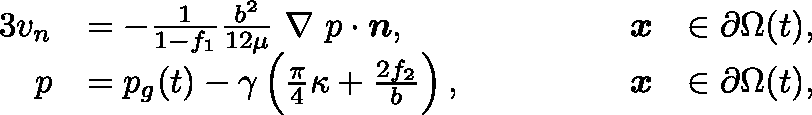<formula> <loc_0><loc_0><loc_500><loc_500>\begin{array} { r l r l } { { 3 } v _ { n } } & { = - \frac { 1 } { 1 - f _ { 1 } } \frac { b ^ { 2 } } { 1 2 \mu } \boldmath \nabla p \cdot n , \quad } & { x } & { \in \partial \Omega ( t ) , } \\ { p } & { = p _ { g } ( t ) - \gamma \left ( \frac { \pi } { 4 } \kappa + \frac { 2 f _ { 2 } } { b } \right ) , \quad } & { x } & { \in \partial \Omega ( t ) , } \end{array}</formula> 